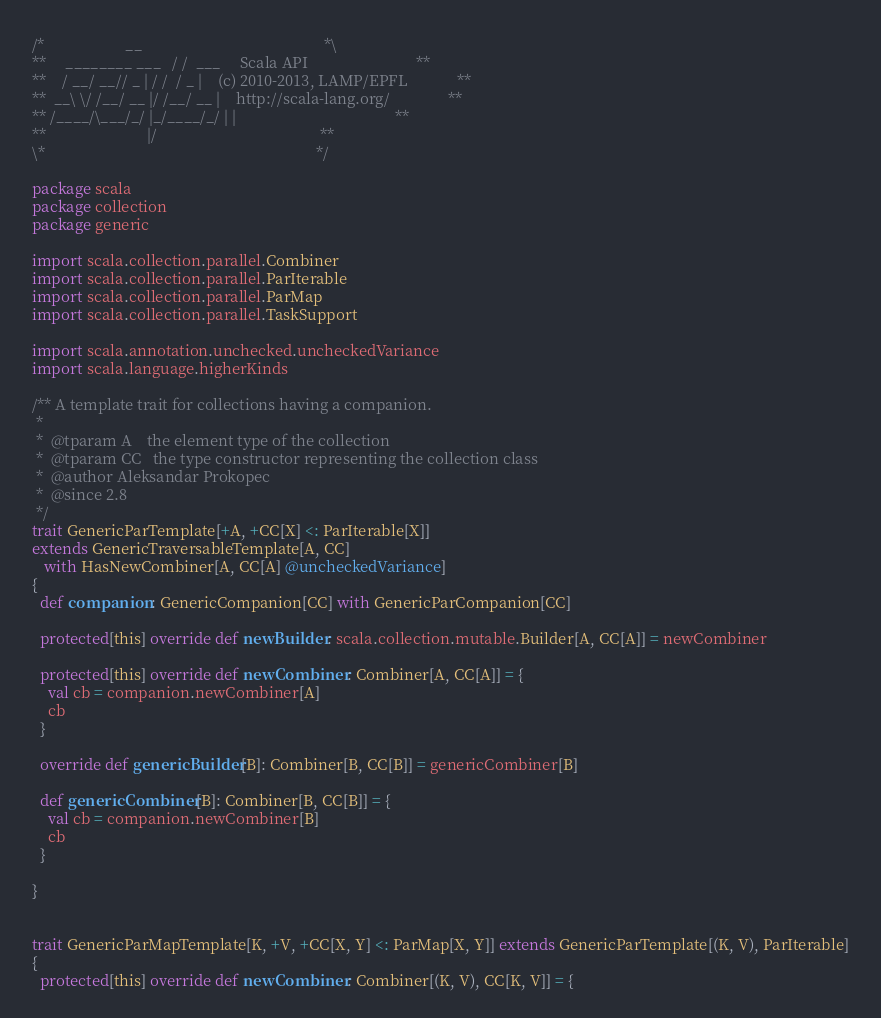Convert code to text. <code><loc_0><loc_0><loc_500><loc_500><_Scala_>/*                     __                                               *\
**     ________ ___   / /  ___     Scala API                            **
**    / __/ __// _ | / /  / _ |    (c) 2010-2013, LAMP/EPFL             **
**  __\ \/ /__/ __ |/ /__/ __ |    http://scala-lang.org/               **
** /____/\___/_/ |_/____/_/ | |                                         **
**                          |/                                          **
\*                                                                      */

package scala
package collection
package generic

import scala.collection.parallel.Combiner
import scala.collection.parallel.ParIterable
import scala.collection.parallel.ParMap
import scala.collection.parallel.TaskSupport

import scala.annotation.unchecked.uncheckedVariance
import scala.language.higherKinds

/** A template trait for collections having a companion.
 *
 *  @tparam A    the element type of the collection
 *  @tparam CC   the type constructor representing the collection class
 *  @author Aleksandar Prokopec
 *  @since 2.8
 */
trait GenericParTemplate[+A, +CC[X] <: ParIterable[X]]
extends GenericTraversableTemplate[A, CC]
   with HasNewCombiner[A, CC[A] @uncheckedVariance]
{
  def companion: GenericCompanion[CC] with GenericParCompanion[CC]

  protected[this] override def newBuilder: scala.collection.mutable.Builder[A, CC[A]] = newCombiner

  protected[this] override def newCombiner: Combiner[A, CC[A]] = {
    val cb = companion.newCombiner[A]
    cb
  }

  override def genericBuilder[B]: Combiner[B, CC[B]] = genericCombiner[B]

  def genericCombiner[B]: Combiner[B, CC[B]] = {
    val cb = companion.newCombiner[B]
    cb
  }

}


trait GenericParMapTemplate[K, +V, +CC[X, Y] <: ParMap[X, Y]] extends GenericParTemplate[(K, V), ParIterable]
{
  protected[this] override def newCombiner: Combiner[(K, V), CC[K, V]] = {</code> 